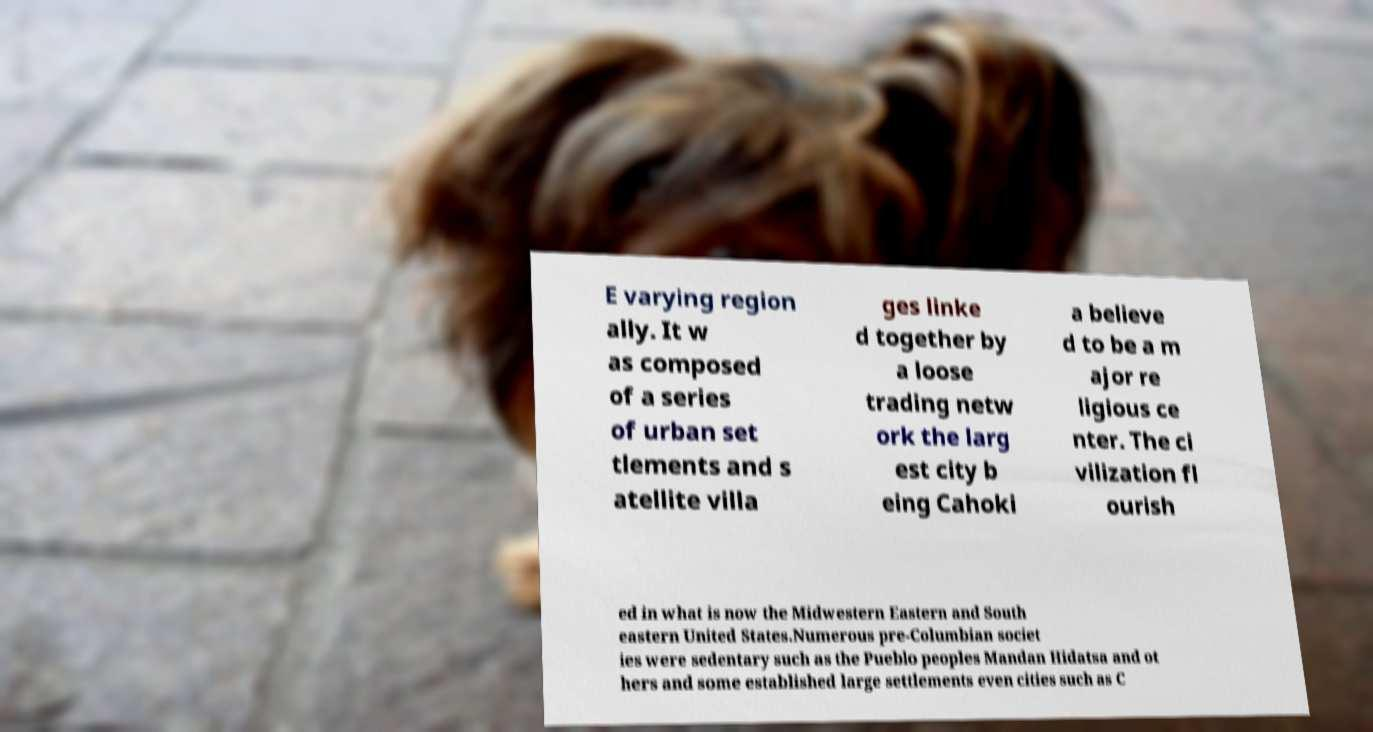Can you read and provide the text displayed in the image?This photo seems to have some interesting text. Can you extract and type it out for me? E varying region ally. It w as composed of a series of urban set tlements and s atellite villa ges linke d together by a loose trading netw ork the larg est city b eing Cahoki a believe d to be a m ajor re ligious ce nter. The ci vilization fl ourish ed in what is now the Midwestern Eastern and South eastern United States.Numerous pre-Columbian societ ies were sedentary such as the Pueblo peoples Mandan Hidatsa and ot hers and some established large settlements even cities such as C 